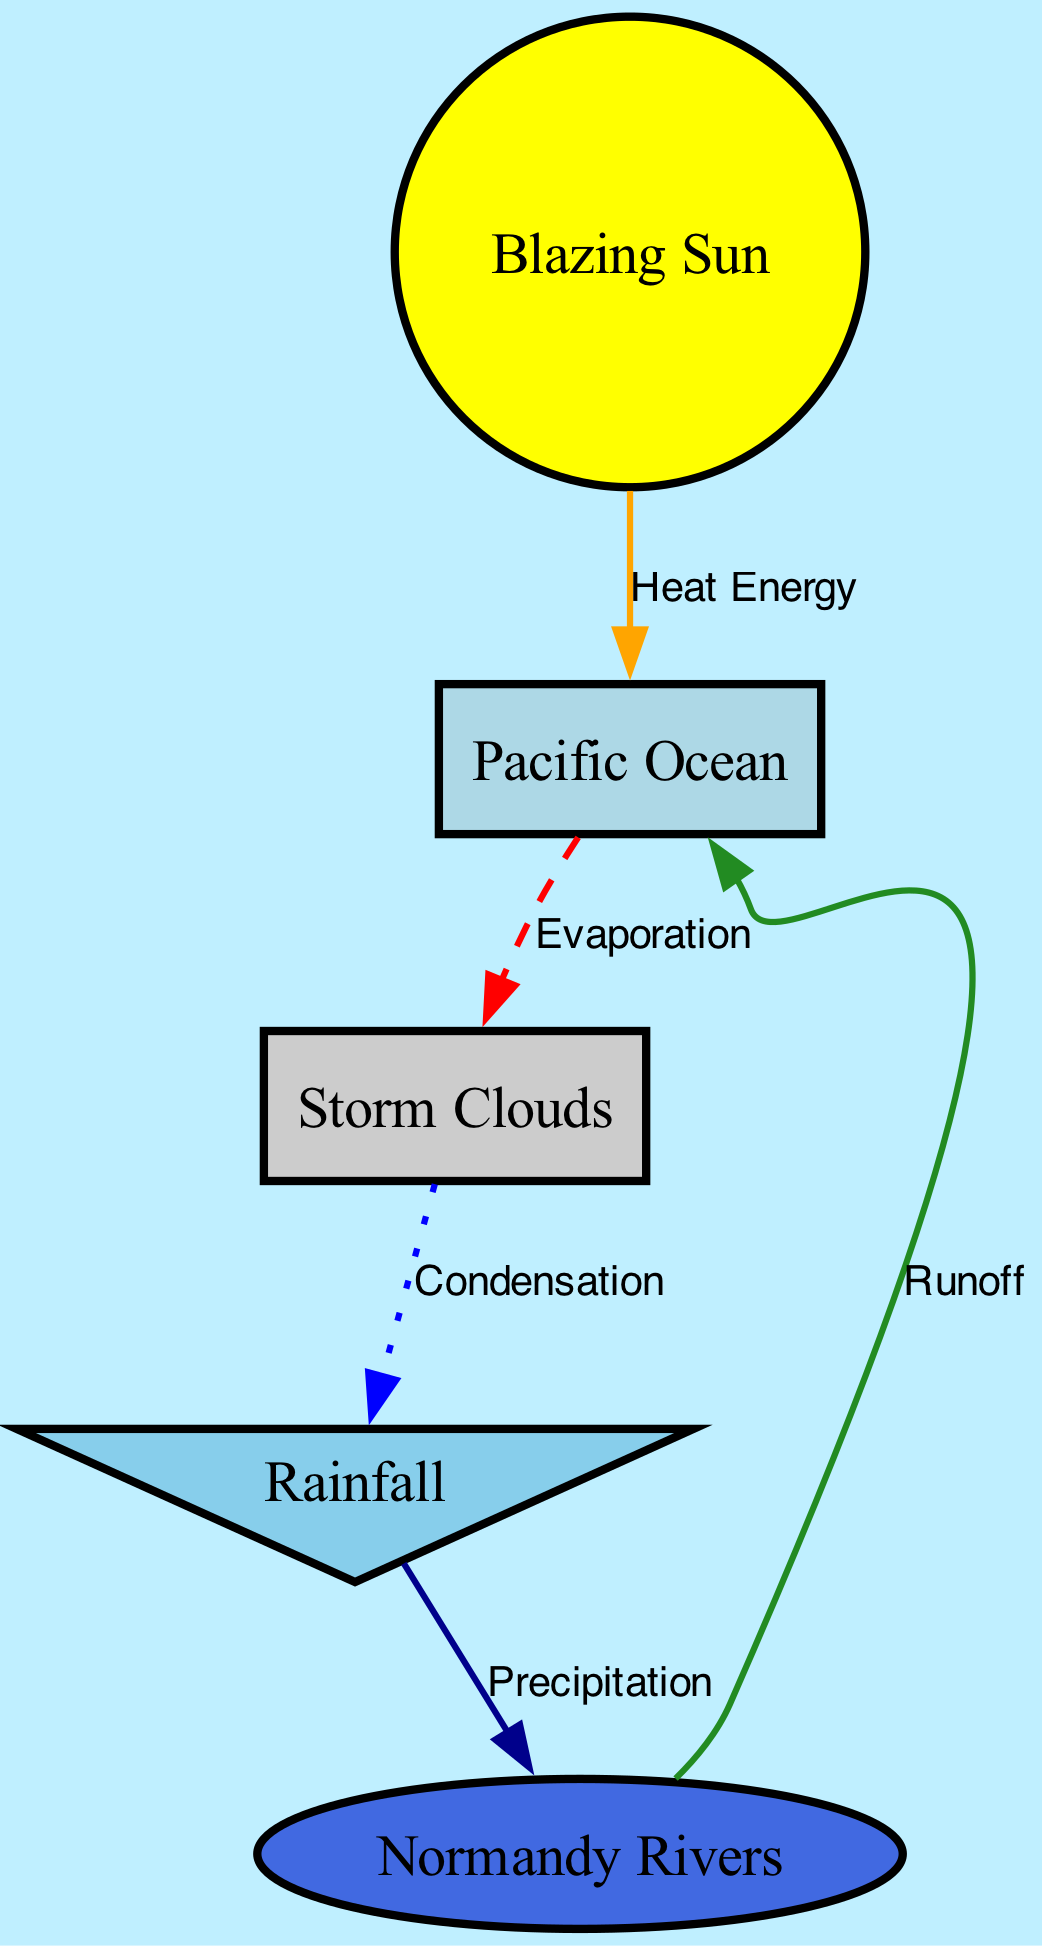What is the first step in the water cycle illustrated in the diagram? The diagram starts with the "Pacific Ocean," which is the source of water that begins the evaporation process. Therefore, evaporation is the first step, leading from the ocean to the clouds.
Answer: Evaporation Which node represents the clouds in the diagram? The "Storm Clouds" node visually represents the clouds in the water cycle diagram, linking the evaporation process from the ocean.
Answer: Storm Clouds How many nodes are depicted in the diagram? By counting the identified nodes (Pacific Ocean, Storm Clouds, Rainfall, Normandy Rivers, Blazing Sun), there are a total of five nodes in the diagram.
Answer: 5 What is the relationship between the clouds and rainfall? The connection between the "Storm Clouds" and "Rainfall" nodes is described as "Condensation," illustrating how moisture in clouds transforms into rainfall.
Answer: Condensation What process connects rainfall back to the ocean? The "Runoff" process illustrated in the diagram shows how water from rainfall flows back into the "Pacific Ocean," closing the water cycle loop.
Answer: Runoff Which natural element provides heat energy to the ocean? The "Blazing Sun" node represents the source of heat energy that contributes to the evaporation process from the ocean.
Answer: Blazing Sun What color indicates the process of evaporation in the diagram? The edges that represent evaporation are colored red and are styled as dashed lines to signify the evaporation process from the ocean to the clouds.
Answer: Red What is the shape of the node representing rain? The "Rainfall" node in the diagram is depicted as an inverted triangle, distinguishing it from the other nodes through its unique shape.
Answer: Inverted Triangle What type of diagram is illustrated here? This diagram is a "Natural Science Diagram" that addresses the water cycle, depicting the processes of evaporation, condensation, and precipitation.
Answer: Natural Science Diagram 